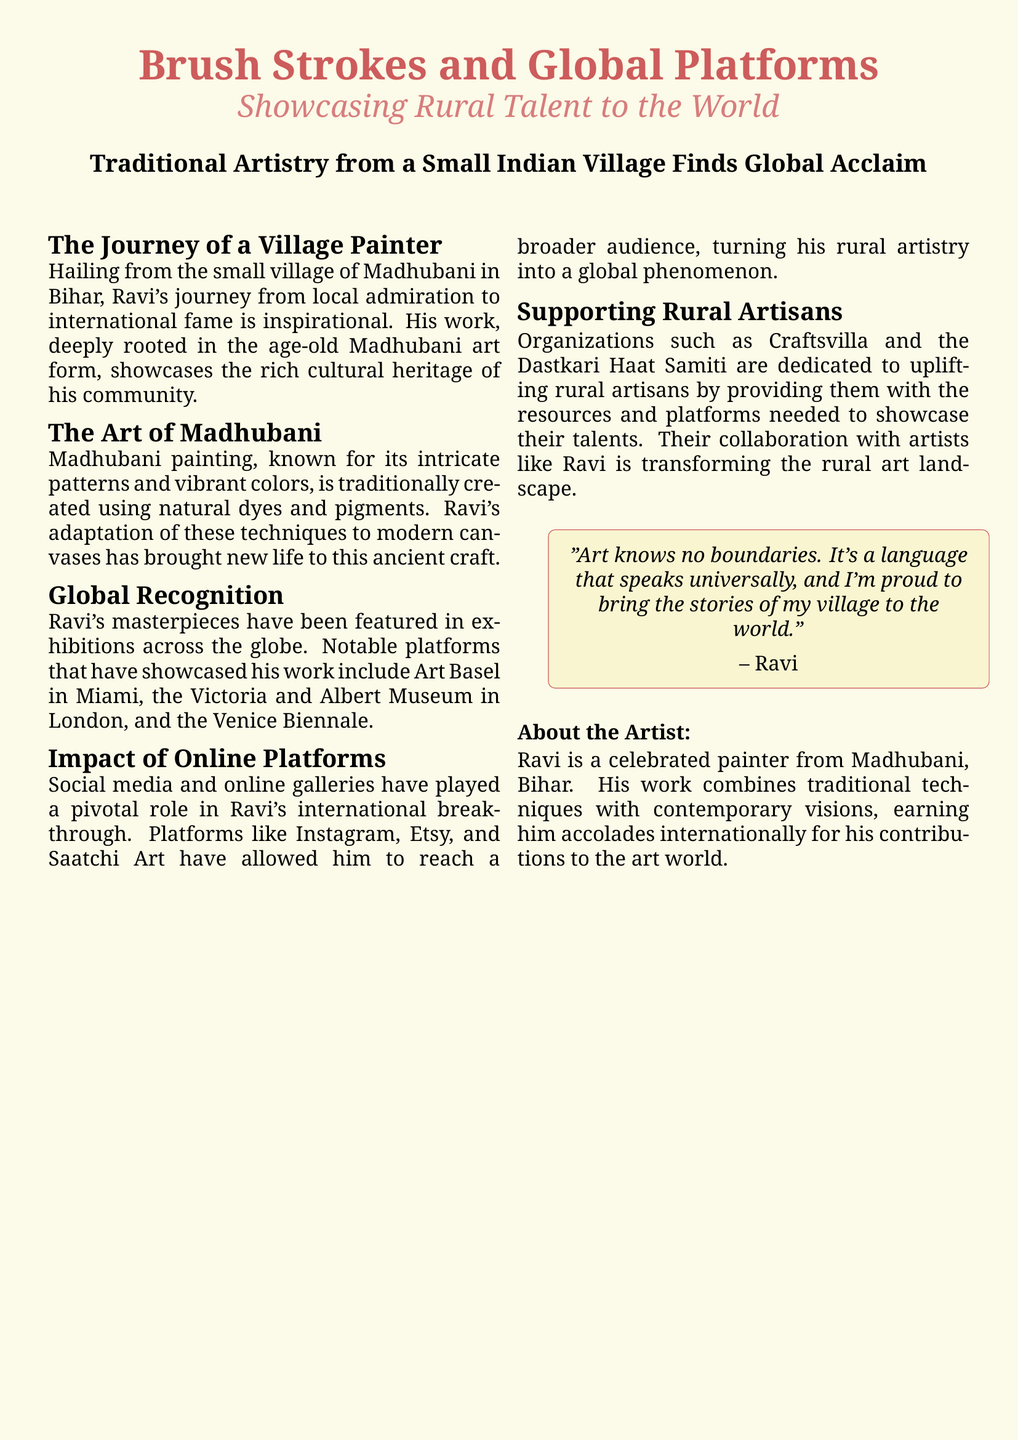What is the name of the village where Ravi is from? The document states that Ravi hails from the small village of Madhubani in Bihar.
Answer: Madhubani What art form is Ravi known for? The document mentions that Ravi's work is deeply rooted in the age-old Madhubani art form.
Answer: Madhubani art Which exhibition in Miami showcased Ravi's work? The document specifically notes that Ravi's masterpieces have been featured at Art Basel in Miami.
Answer: Art Basel What platforms helped Ravi reach a broader audience? The document lists Instagram, Etsy, and Saatchi Art as pivotal for Ravi's international breakthrough.
Answer: Instagram, Etsy, and Saatchi Art Which organization supports rural artisans like Ravi? The document mentions Craftsvilla as an organization dedicated to uplifting rural artisans.
Answer: Craftsvilla What unique aspect does Ravi incorporate into his painting technique? The document states that Ravi adapts traditional techniques to modern canvases.
Answer: Modern canvases Who is quoted in the document about art knowing no boundaries? The quote in the document is attributed to Ravi.
Answer: Ravi What is the color theme used in the magazine layout? The document describes the page color as khaki with accents of indianred.
Answer: khaki and indianred 